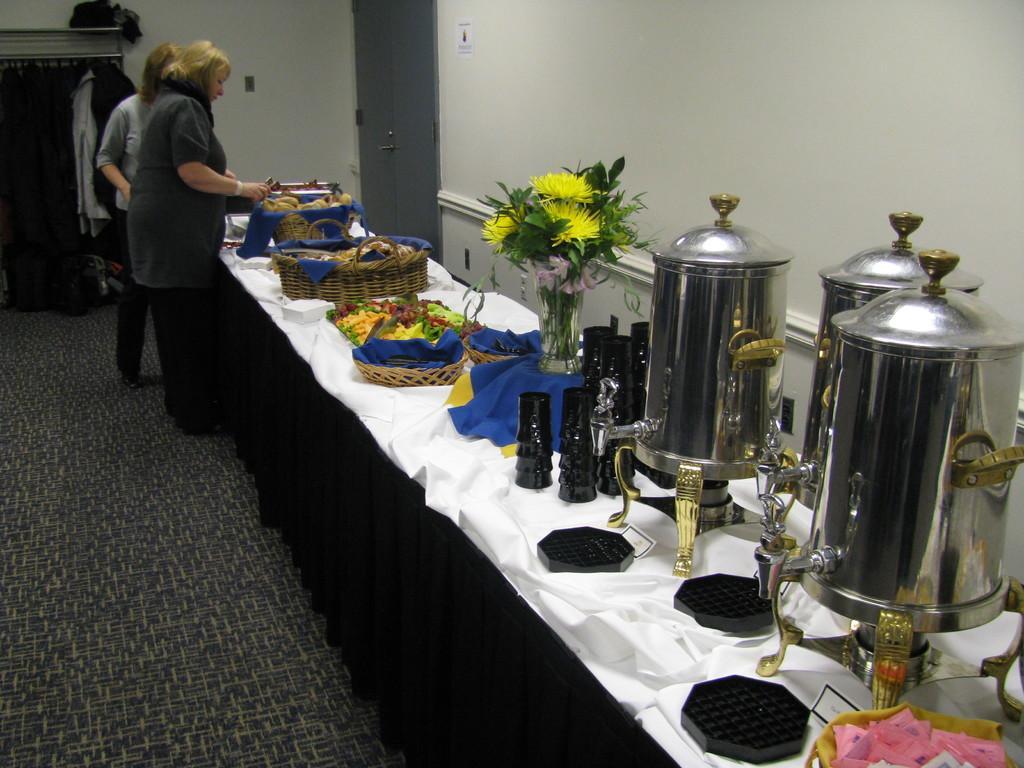Describe this image in one or two sentences. In this image, we can see a table covered with clothes. Few things, baskets, containers, flower vase is placed on it. On the left side of the image, we can see a floor, two people are standing. Background we can see a wall, doors, poster, few clothes, rods. Here a woman is holding an object. 